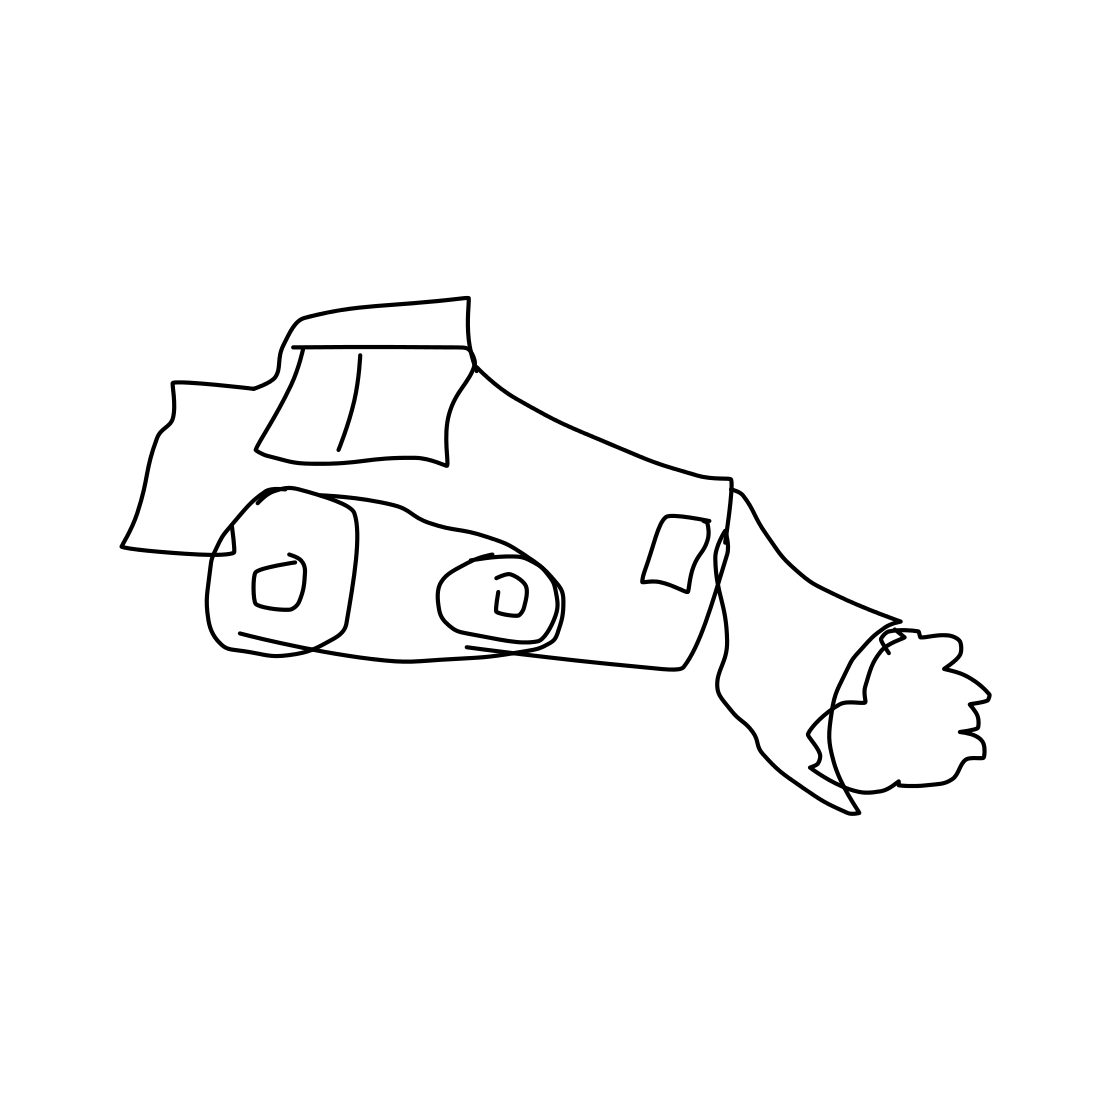What kind of vehicle is shown in this picture? The picture appears to show a stylized, possibly cartoonish representation of a racing car, characterized by its sleek shape and implied speed. 